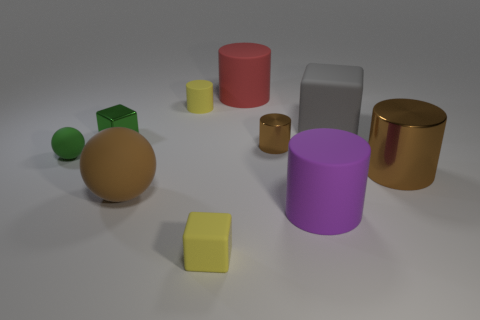The big object that is the same color as the large sphere is what shape? cylinder 